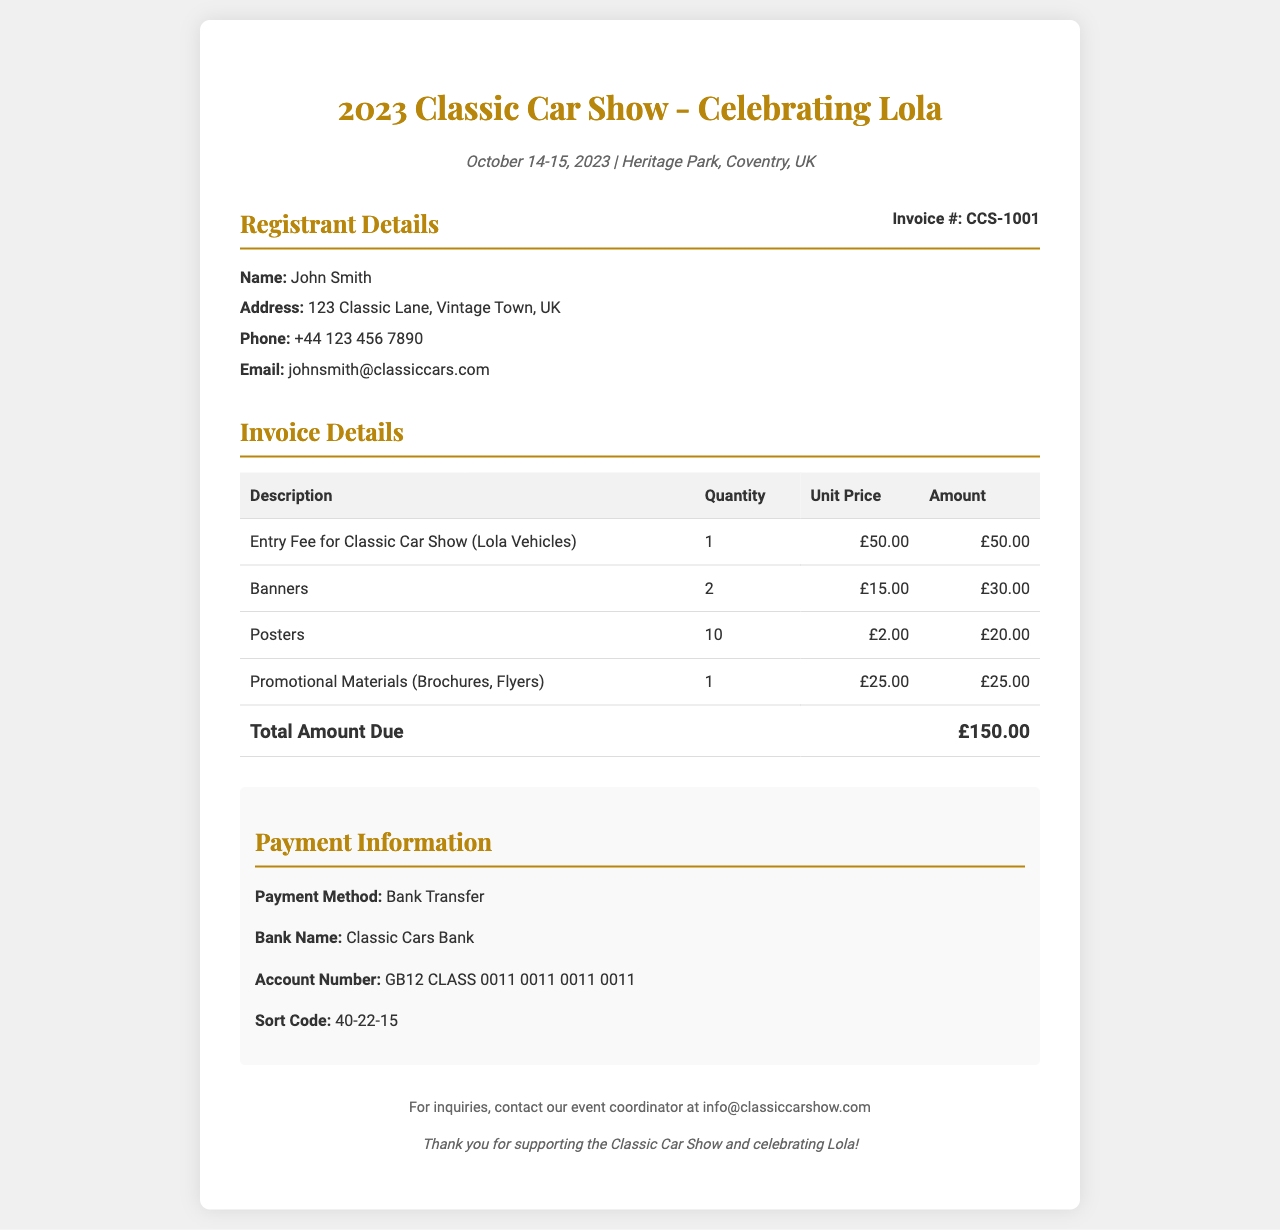What is the event date? The event date is mentioned in the document as October 14-15, 2023.
Answer: October 14-15, 2023 Who is the registrant? The registrant's name is provided in the document as John Smith.
Answer: John Smith What is the total amount due? The total amount due is clearly stated in the invoice table as £150.00.
Answer: £150.00 How many banners were ordered? The invoice lists the quantity of banners ordered as 2.
Answer: 2 What payment method is used? The payment method is specified in the payment information section as Bank Transfer.
Answer: Bank Transfer What is the entry fee for the Classic Car Show? The entry fee for the Classic Car Show is shown as £50.00 in the invoice.
Answer: £50.00 How many posters are included in the order? The invoice states that 10 posters were ordered.
Answer: 10 What is the address of the registrant? The registrant's address is detailed as 123 Classic Lane, Vintage Town, UK.
Answer: 123 Classic Lane, Vintage Town, UK What bank is mentioned for the payment? The bank name for the payment is listed as Classic Cars Bank.
Answer: Classic Cars Bank 